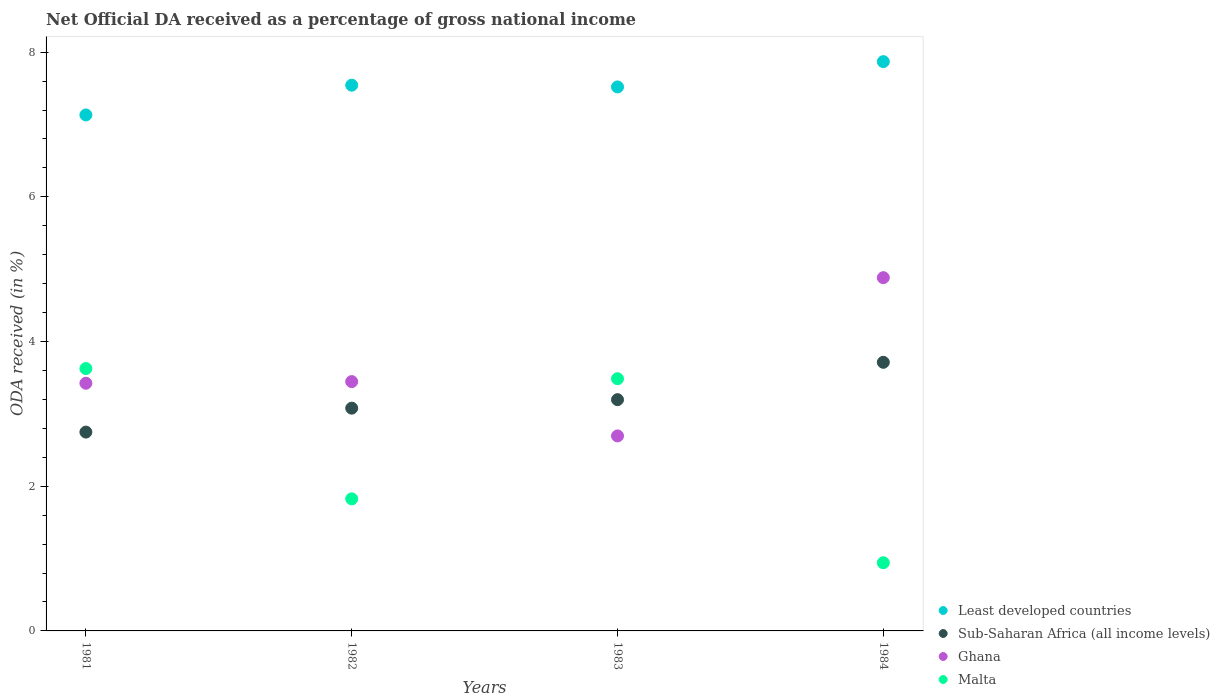What is the net official DA received in Malta in 1983?
Your response must be concise. 3.49. Across all years, what is the maximum net official DA received in Ghana?
Keep it short and to the point. 4.88. Across all years, what is the minimum net official DA received in Least developed countries?
Give a very brief answer. 7.13. In which year was the net official DA received in Sub-Saharan Africa (all income levels) maximum?
Provide a succinct answer. 1984. In which year was the net official DA received in Sub-Saharan Africa (all income levels) minimum?
Offer a very short reply. 1981. What is the total net official DA received in Least developed countries in the graph?
Your answer should be compact. 30.06. What is the difference between the net official DA received in Malta in 1983 and that in 1984?
Provide a succinct answer. 2.54. What is the difference between the net official DA received in Ghana in 1984 and the net official DA received in Malta in 1983?
Offer a terse response. 1.4. What is the average net official DA received in Sub-Saharan Africa (all income levels) per year?
Provide a short and direct response. 3.18. In the year 1984, what is the difference between the net official DA received in Ghana and net official DA received in Malta?
Provide a short and direct response. 3.94. In how many years, is the net official DA received in Sub-Saharan Africa (all income levels) greater than 4.4 %?
Offer a very short reply. 0. What is the ratio of the net official DA received in Sub-Saharan Africa (all income levels) in 1982 to that in 1983?
Your answer should be compact. 0.96. Is the difference between the net official DA received in Ghana in 1981 and 1983 greater than the difference between the net official DA received in Malta in 1981 and 1983?
Your response must be concise. Yes. What is the difference between the highest and the second highest net official DA received in Malta?
Keep it short and to the point. 0.14. What is the difference between the highest and the lowest net official DA received in Sub-Saharan Africa (all income levels)?
Provide a succinct answer. 0.96. Is the sum of the net official DA received in Sub-Saharan Africa (all income levels) in 1983 and 1984 greater than the maximum net official DA received in Ghana across all years?
Your answer should be compact. Yes. Is the net official DA received in Least developed countries strictly greater than the net official DA received in Ghana over the years?
Offer a terse response. Yes. Is the net official DA received in Malta strictly less than the net official DA received in Sub-Saharan Africa (all income levels) over the years?
Your answer should be compact. No. How many years are there in the graph?
Provide a short and direct response. 4. Does the graph contain grids?
Keep it short and to the point. No. How many legend labels are there?
Provide a succinct answer. 4. How are the legend labels stacked?
Give a very brief answer. Vertical. What is the title of the graph?
Provide a short and direct response. Net Official DA received as a percentage of gross national income. Does "Fiji" appear as one of the legend labels in the graph?
Your response must be concise. No. What is the label or title of the Y-axis?
Make the answer very short. ODA received (in %). What is the ODA received (in %) in Least developed countries in 1981?
Your response must be concise. 7.13. What is the ODA received (in %) of Sub-Saharan Africa (all income levels) in 1981?
Your answer should be compact. 2.75. What is the ODA received (in %) in Ghana in 1981?
Your answer should be compact. 3.42. What is the ODA received (in %) of Malta in 1981?
Your answer should be very brief. 3.63. What is the ODA received (in %) of Least developed countries in 1982?
Keep it short and to the point. 7.54. What is the ODA received (in %) of Sub-Saharan Africa (all income levels) in 1982?
Keep it short and to the point. 3.08. What is the ODA received (in %) in Ghana in 1982?
Ensure brevity in your answer.  3.45. What is the ODA received (in %) of Malta in 1982?
Give a very brief answer. 1.83. What is the ODA received (in %) of Least developed countries in 1983?
Your response must be concise. 7.52. What is the ODA received (in %) of Sub-Saharan Africa (all income levels) in 1983?
Your response must be concise. 3.2. What is the ODA received (in %) of Ghana in 1983?
Offer a terse response. 2.7. What is the ODA received (in %) in Malta in 1983?
Ensure brevity in your answer.  3.49. What is the ODA received (in %) in Least developed countries in 1984?
Your response must be concise. 7.87. What is the ODA received (in %) of Sub-Saharan Africa (all income levels) in 1984?
Offer a very short reply. 3.71. What is the ODA received (in %) of Ghana in 1984?
Your answer should be compact. 4.88. What is the ODA received (in %) of Malta in 1984?
Offer a very short reply. 0.94. Across all years, what is the maximum ODA received (in %) of Least developed countries?
Give a very brief answer. 7.87. Across all years, what is the maximum ODA received (in %) in Sub-Saharan Africa (all income levels)?
Your response must be concise. 3.71. Across all years, what is the maximum ODA received (in %) in Ghana?
Offer a very short reply. 4.88. Across all years, what is the maximum ODA received (in %) of Malta?
Offer a terse response. 3.63. Across all years, what is the minimum ODA received (in %) of Least developed countries?
Ensure brevity in your answer.  7.13. Across all years, what is the minimum ODA received (in %) of Sub-Saharan Africa (all income levels)?
Your answer should be very brief. 2.75. Across all years, what is the minimum ODA received (in %) in Ghana?
Make the answer very short. 2.7. Across all years, what is the minimum ODA received (in %) in Malta?
Keep it short and to the point. 0.94. What is the total ODA received (in %) in Least developed countries in the graph?
Make the answer very short. 30.06. What is the total ODA received (in %) in Sub-Saharan Africa (all income levels) in the graph?
Your response must be concise. 12.74. What is the total ODA received (in %) in Ghana in the graph?
Give a very brief answer. 14.45. What is the total ODA received (in %) of Malta in the graph?
Provide a succinct answer. 9.88. What is the difference between the ODA received (in %) in Least developed countries in 1981 and that in 1982?
Make the answer very short. -0.41. What is the difference between the ODA received (in %) of Sub-Saharan Africa (all income levels) in 1981 and that in 1982?
Your answer should be very brief. -0.33. What is the difference between the ODA received (in %) in Ghana in 1981 and that in 1982?
Make the answer very short. -0.02. What is the difference between the ODA received (in %) of Malta in 1981 and that in 1982?
Give a very brief answer. 1.8. What is the difference between the ODA received (in %) in Least developed countries in 1981 and that in 1983?
Give a very brief answer. -0.39. What is the difference between the ODA received (in %) in Sub-Saharan Africa (all income levels) in 1981 and that in 1983?
Ensure brevity in your answer.  -0.45. What is the difference between the ODA received (in %) in Ghana in 1981 and that in 1983?
Your answer should be very brief. 0.73. What is the difference between the ODA received (in %) in Malta in 1981 and that in 1983?
Provide a succinct answer. 0.14. What is the difference between the ODA received (in %) in Least developed countries in 1981 and that in 1984?
Ensure brevity in your answer.  -0.74. What is the difference between the ODA received (in %) in Sub-Saharan Africa (all income levels) in 1981 and that in 1984?
Keep it short and to the point. -0.96. What is the difference between the ODA received (in %) of Ghana in 1981 and that in 1984?
Give a very brief answer. -1.46. What is the difference between the ODA received (in %) of Malta in 1981 and that in 1984?
Offer a terse response. 2.68. What is the difference between the ODA received (in %) in Least developed countries in 1982 and that in 1983?
Offer a terse response. 0.02. What is the difference between the ODA received (in %) of Sub-Saharan Africa (all income levels) in 1982 and that in 1983?
Your response must be concise. -0.12. What is the difference between the ODA received (in %) of Ghana in 1982 and that in 1983?
Ensure brevity in your answer.  0.75. What is the difference between the ODA received (in %) of Malta in 1982 and that in 1983?
Keep it short and to the point. -1.66. What is the difference between the ODA received (in %) of Least developed countries in 1982 and that in 1984?
Provide a short and direct response. -0.33. What is the difference between the ODA received (in %) in Sub-Saharan Africa (all income levels) in 1982 and that in 1984?
Offer a terse response. -0.63. What is the difference between the ODA received (in %) in Ghana in 1982 and that in 1984?
Provide a short and direct response. -1.44. What is the difference between the ODA received (in %) in Malta in 1982 and that in 1984?
Ensure brevity in your answer.  0.88. What is the difference between the ODA received (in %) in Least developed countries in 1983 and that in 1984?
Make the answer very short. -0.35. What is the difference between the ODA received (in %) in Sub-Saharan Africa (all income levels) in 1983 and that in 1984?
Offer a terse response. -0.52. What is the difference between the ODA received (in %) in Ghana in 1983 and that in 1984?
Give a very brief answer. -2.19. What is the difference between the ODA received (in %) of Malta in 1983 and that in 1984?
Keep it short and to the point. 2.54. What is the difference between the ODA received (in %) of Least developed countries in 1981 and the ODA received (in %) of Sub-Saharan Africa (all income levels) in 1982?
Your response must be concise. 4.05. What is the difference between the ODA received (in %) in Least developed countries in 1981 and the ODA received (in %) in Ghana in 1982?
Offer a terse response. 3.69. What is the difference between the ODA received (in %) of Least developed countries in 1981 and the ODA received (in %) of Malta in 1982?
Your answer should be very brief. 5.31. What is the difference between the ODA received (in %) of Sub-Saharan Africa (all income levels) in 1981 and the ODA received (in %) of Ghana in 1982?
Your response must be concise. -0.7. What is the difference between the ODA received (in %) in Sub-Saharan Africa (all income levels) in 1981 and the ODA received (in %) in Malta in 1982?
Make the answer very short. 0.92. What is the difference between the ODA received (in %) in Ghana in 1981 and the ODA received (in %) in Malta in 1982?
Provide a succinct answer. 1.6. What is the difference between the ODA received (in %) in Least developed countries in 1981 and the ODA received (in %) in Sub-Saharan Africa (all income levels) in 1983?
Your answer should be compact. 3.94. What is the difference between the ODA received (in %) in Least developed countries in 1981 and the ODA received (in %) in Ghana in 1983?
Give a very brief answer. 4.44. What is the difference between the ODA received (in %) of Least developed countries in 1981 and the ODA received (in %) of Malta in 1983?
Offer a very short reply. 3.65. What is the difference between the ODA received (in %) in Sub-Saharan Africa (all income levels) in 1981 and the ODA received (in %) in Ghana in 1983?
Ensure brevity in your answer.  0.05. What is the difference between the ODA received (in %) of Sub-Saharan Africa (all income levels) in 1981 and the ODA received (in %) of Malta in 1983?
Your response must be concise. -0.74. What is the difference between the ODA received (in %) of Ghana in 1981 and the ODA received (in %) of Malta in 1983?
Your answer should be compact. -0.06. What is the difference between the ODA received (in %) of Least developed countries in 1981 and the ODA received (in %) of Sub-Saharan Africa (all income levels) in 1984?
Provide a succinct answer. 3.42. What is the difference between the ODA received (in %) of Least developed countries in 1981 and the ODA received (in %) of Ghana in 1984?
Your answer should be very brief. 2.25. What is the difference between the ODA received (in %) in Least developed countries in 1981 and the ODA received (in %) in Malta in 1984?
Ensure brevity in your answer.  6.19. What is the difference between the ODA received (in %) in Sub-Saharan Africa (all income levels) in 1981 and the ODA received (in %) in Ghana in 1984?
Your answer should be very brief. -2.13. What is the difference between the ODA received (in %) of Sub-Saharan Africa (all income levels) in 1981 and the ODA received (in %) of Malta in 1984?
Offer a very short reply. 1.81. What is the difference between the ODA received (in %) of Ghana in 1981 and the ODA received (in %) of Malta in 1984?
Give a very brief answer. 2.48. What is the difference between the ODA received (in %) in Least developed countries in 1982 and the ODA received (in %) in Sub-Saharan Africa (all income levels) in 1983?
Ensure brevity in your answer.  4.35. What is the difference between the ODA received (in %) of Least developed countries in 1982 and the ODA received (in %) of Ghana in 1983?
Offer a very short reply. 4.85. What is the difference between the ODA received (in %) in Least developed countries in 1982 and the ODA received (in %) in Malta in 1983?
Offer a very short reply. 4.06. What is the difference between the ODA received (in %) of Sub-Saharan Africa (all income levels) in 1982 and the ODA received (in %) of Ghana in 1983?
Provide a succinct answer. 0.38. What is the difference between the ODA received (in %) in Sub-Saharan Africa (all income levels) in 1982 and the ODA received (in %) in Malta in 1983?
Ensure brevity in your answer.  -0.41. What is the difference between the ODA received (in %) of Ghana in 1982 and the ODA received (in %) of Malta in 1983?
Your response must be concise. -0.04. What is the difference between the ODA received (in %) of Least developed countries in 1982 and the ODA received (in %) of Sub-Saharan Africa (all income levels) in 1984?
Provide a succinct answer. 3.83. What is the difference between the ODA received (in %) of Least developed countries in 1982 and the ODA received (in %) of Ghana in 1984?
Provide a succinct answer. 2.66. What is the difference between the ODA received (in %) of Least developed countries in 1982 and the ODA received (in %) of Malta in 1984?
Keep it short and to the point. 6.6. What is the difference between the ODA received (in %) of Sub-Saharan Africa (all income levels) in 1982 and the ODA received (in %) of Ghana in 1984?
Make the answer very short. -1.8. What is the difference between the ODA received (in %) of Sub-Saharan Africa (all income levels) in 1982 and the ODA received (in %) of Malta in 1984?
Provide a short and direct response. 2.14. What is the difference between the ODA received (in %) of Ghana in 1982 and the ODA received (in %) of Malta in 1984?
Give a very brief answer. 2.5. What is the difference between the ODA received (in %) in Least developed countries in 1983 and the ODA received (in %) in Sub-Saharan Africa (all income levels) in 1984?
Provide a succinct answer. 3.81. What is the difference between the ODA received (in %) in Least developed countries in 1983 and the ODA received (in %) in Ghana in 1984?
Make the answer very short. 2.64. What is the difference between the ODA received (in %) of Least developed countries in 1983 and the ODA received (in %) of Malta in 1984?
Provide a succinct answer. 6.58. What is the difference between the ODA received (in %) in Sub-Saharan Africa (all income levels) in 1983 and the ODA received (in %) in Ghana in 1984?
Your answer should be compact. -1.69. What is the difference between the ODA received (in %) of Sub-Saharan Africa (all income levels) in 1983 and the ODA received (in %) of Malta in 1984?
Ensure brevity in your answer.  2.25. What is the difference between the ODA received (in %) of Ghana in 1983 and the ODA received (in %) of Malta in 1984?
Make the answer very short. 1.75. What is the average ODA received (in %) in Least developed countries per year?
Offer a terse response. 7.52. What is the average ODA received (in %) of Sub-Saharan Africa (all income levels) per year?
Keep it short and to the point. 3.18. What is the average ODA received (in %) in Ghana per year?
Ensure brevity in your answer.  3.61. What is the average ODA received (in %) of Malta per year?
Keep it short and to the point. 2.47. In the year 1981, what is the difference between the ODA received (in %) of Least developed countries and ODA received (in %) of Sub-Saharan Africa (all income levels)?
Your answer should be compact. 4.38. In the year 1981, what is the difference between the ODA received (in %) of Least developed countries and ODA received (in %) of Ghana?
Your response must be concise. 3.71. In the year 1981, what is the difference between the ODA received (in %) in Least developed countries and ODA received (in %) in Malta?
Your response must be concise. 3.51. In the year 1981, what is the difference between the ODA received (in %) in Sub-Saharan Africa (all income levels) and ODA received (in %) in Ghana?
Your answer should be compact. -0.68. In the year 1981, what is the difference between the ODA received (in %) in Sub-Saharan Africa (all income levels) and ODA received (in %) in Malta?
Offer a terse response. -0.88. In the year 1981, what is the difference between the ODA received (in %) in Ghana and ODA received (in %) in Malta?
Give a very brief answer. -0.2. In the year 1982, what is the difference between the ODA received (in %) of Least developed countries and ODA received (in %) of Sub-Saharan Africa (all income levels)?
Keep it short and to the point. 4.46. In the year 1982, what is the difference between the ODA received (in %) in Least developed countries and ODA received (in %) in Ghana?
Provide a succinct answer. 4.1. In the year 1982, what is the difference between the ODA received (in %) of Least developed countries and ODA received (in %) of Malta?
Your response must be concise. 5.72. In the year 1982, what is the difference between the ODA received (in %) of Sub-Saharan Africa (all income levels) and ODA received (in %) of Ghana?
Your answer should be compact. -0.37. In the year 1982, what is the difference between the ODA received (in %) in Sub-Saharan Africa (all income levels) and ODA received (in %) in Malta?
Your answer should be very brief. 1.25. In the year 1982, what is the difference between the ODA received (in %) in Ghana and ODA received (in %) in Malta?
Ensure brevity in your answer.  1.62. In the year 1983, what is the difference between the ODA received (in %) in Least developed countries and ODA received (in %) in Sub-Saharan Africa (all income levels)?
Provide a succinct answer. 4.32. In the year 1983, what is the difference between the ODA received (in %) of Least developed countries and ODA received (in %) of Ghana?
Your answer should be compact. 4.82. In the year 1983, what is the difference between the ODA received (in %) in Least developed countries and ODA received (in %) in Malta?
Your answer should be compact. 4.03. In the year 1983, what is the difference between the ODA received (in %) in Sub-Saharan Africa (all income levels) and ODA received (in %) in Ghana?
Ensure brevity in your answer.  0.5. In the year 1983, what is the difference between the ODA received (in %) of Sub-Saharan Africa (all income levels) and ODA received (in %) of Malta?
Ensure brevity in your answer.  -0.29. In the year 1983, what is the difference between the ODA received (in %) in Ghana and ODA received (in %) in Malta?
Provide a short and direct response. -0.79. In the year 1984, what is the difference between the ODA received (in %) of Least developed countries and ODA received (in %) of Sub-Saharan Africa (all income levels)?
Provide a succinct answer. 4.16. In the year 1984, what is the difference between the ODA received (in %) of Least developed countries and ODA received (in %) of Ghana?
Offer a terse response. 2.99. In the year 1984, what is the difference between the ODA received (in %) in Least developed countries and ODA received (in %) in Malta?
Keep it short and to the point. 6.93. In the year 1984, what is the difference between the ODA received (in %) of Sub-Saharan Africa (all income levels) and ODA received (in %) of Ghana?
Your answer should be compact. -1.17. In the year 1984, what is the difference between the ODA received (in %) in Sub-Saharan Africa (all income levels) and ODA received (in %) in Malta?
Your answer should be compact. 2.77. In the year 1984, what is the difference between the ODA received (in %) of Ghana and ODA received (in %) of Malta?
Your answer should be compact. 3.94. What is the ratio of the ODA received (in %) in Least developed countries in 1981 to that in 1982?
Your answer should be very brief. 0.95. What is the ratio of the ODA received (in %) in Sub-Saharan Africa (all income levels) in 1981 to that in 1982?
Make the answer very short. 0.89. What is the ratio of the ODA received (in %) in Malta in 1981 to that in 1982?
Your answer should be very brief. 1.99. What is the ratio of the ODA received (in %) in Least developed countries in 1981 to that in 1983?
Ensure brevity in your answer.  0.95. What is the ratio of the ODA received (in %) of Sub-Saharan Africa (all income levels) in 1981 to that in 1983?
Your answer should be compact. 0.86. What is the ratio of the ODA received (in %) of Ghana in 1981 to that in 1983?
Keep it short and to the point. 1.27. What is the ratio of the ODA received (in %) of Malta in 1981 to that in 1983?
Your answer should be compact. 1.04. What is the ratio of the ODA received (in %) of Least developed countries in 1981 to that in 1984?
Your answer should be very brief. 0.91. What is the ratio of the ODA received (in %) of Sub-Saharan Africa (all income levels) in 1981 to that in 1984?
Provide a short and direct response. 0.74. What is the ratio of the ODA received (in %) in Ghana in 1981 to that in 1984?
Make the answer very short. 0.7. What is the ratio of the ODA received (in %) of Malta in 1981 to that in 1984?
Ensure brevity in your answer.  3.85. What is the ratio of the ODA received (in %) of Sub-Saharan Africa (all income levels) in 1982 to that in 1983?
Offer a terse response. 0.96. What is the ratio of the ODA received (in %) of Ghana in 1982 to that in 1983?
Offer a very short reply. 1.28. What is the ratio of the ODA received (in %) in Malta in 1982 to that in 1983?
Make the answer very short. 0.52. What is the ratio of the ODA received (in %) in Least developed countries in 1982 to that in 1984?
Offer a very short reply. 0.96. What is the ratio of the ODA received (in %) of Sub-Saharan Africa (all income levels) in 1982 to that in 1984?
Provide a short and direct response. 0.83. What is the ratio of the ODA received (in %) of Ghana in 1982 to that in 1984?
Make the answer very short. 0.71. What is the ratio of the ODA received (in %) of Malta in 1982 to that in 1984?
Ensure brevity in your answer.  1.94. What is the ratio of the ODA received (in %) of Least developed countries in 1983 to that in 1984?
Your response must be concise. 0.96. What is the ratio of the ODA received (in %) in Sub-Saharan Africa (all income levels) in 1983 to that in 1984?
Keep it short and to the point. 0.86. What is the ratio of the ODA received (in %) of Ghana in 1983 to that in 1984?
Provide a short and direct response. 0.55. What is the ratio of the ODA received (in %) of Malta in 1983 to that in 1984?
Ensure brevity in your answer.  3.7. What is the difference between the highest and the second highest ODA received (in %) in Least developed countries?
Offer a very short reply. 0.33. What is the difference between the highest and the second highest ODA received (in %) in Sub-Saharan Africa (all income levels)?
Your response must be concise. 0.52. What is the difference between the highest and the second highest ODA received (in %) of Ghana?
Give a very brief answer. 1.44. What is the difference between the highest and the second highest ODA received (in %) of Malta?
Your response must be concise. 0.14. What is the difference between the highest and the lowest ODA received (in %) in Least developed countries?
Offer a very short reply. 0.74. What is the difference between the highest and the lowest ODA received (in %) of Sub-Saharan Africa (all income levels)?
Offer a terse response. 0.96. What is the difference between the highest and the lowest ODA received (in %) in Ghana?
Give a very brief answer. 2.19. What is the difference between the highest and the lowest ODA received (in %) in Malta?
Your answer should be compact. 2.68. 